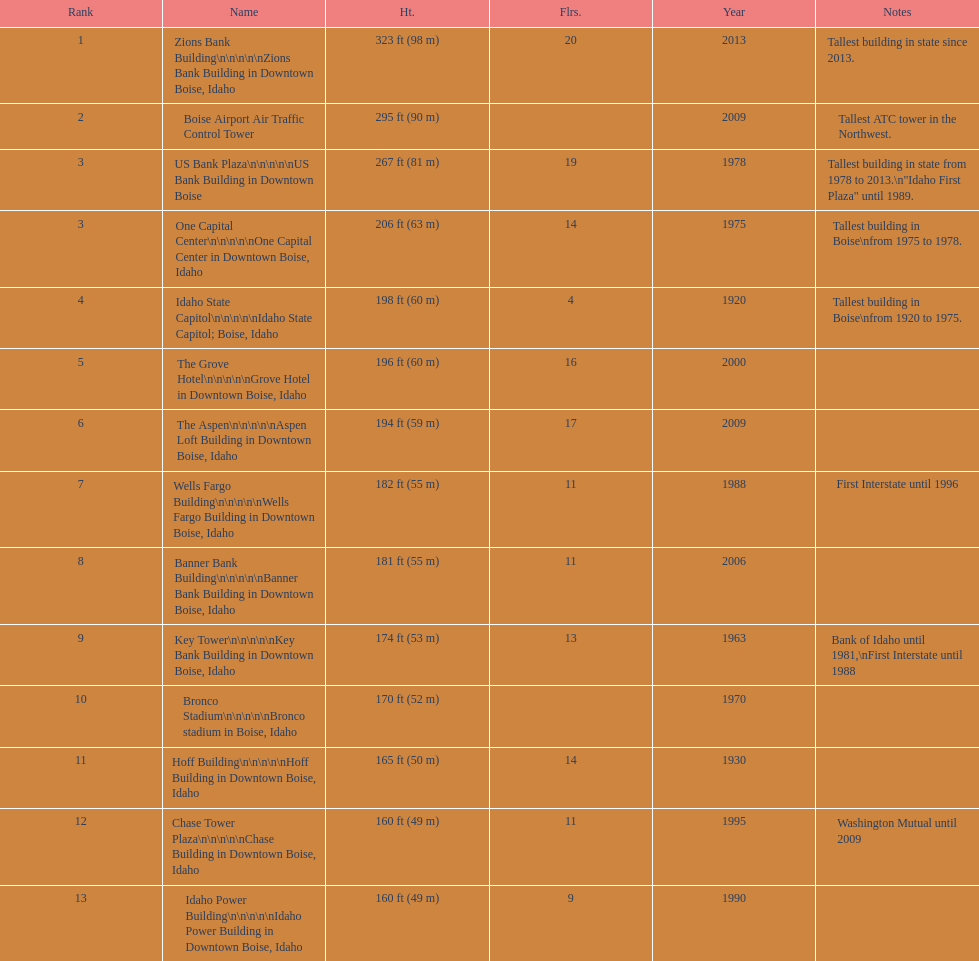How many of these buildings were built after 1975 8. 